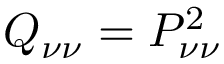<formula> <loc_0><loc_0><loc_500><loc_500>Q _ { \nu \nu } = P _ { \nu \nu } ^ { 2 }</formula> 